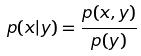Convert formula to latex. <formula><loc_0><loc_0><loc_500><loc_500>p ( x | y ) = \frac { p ( x , y ) } { p ( y ) }</formula> 